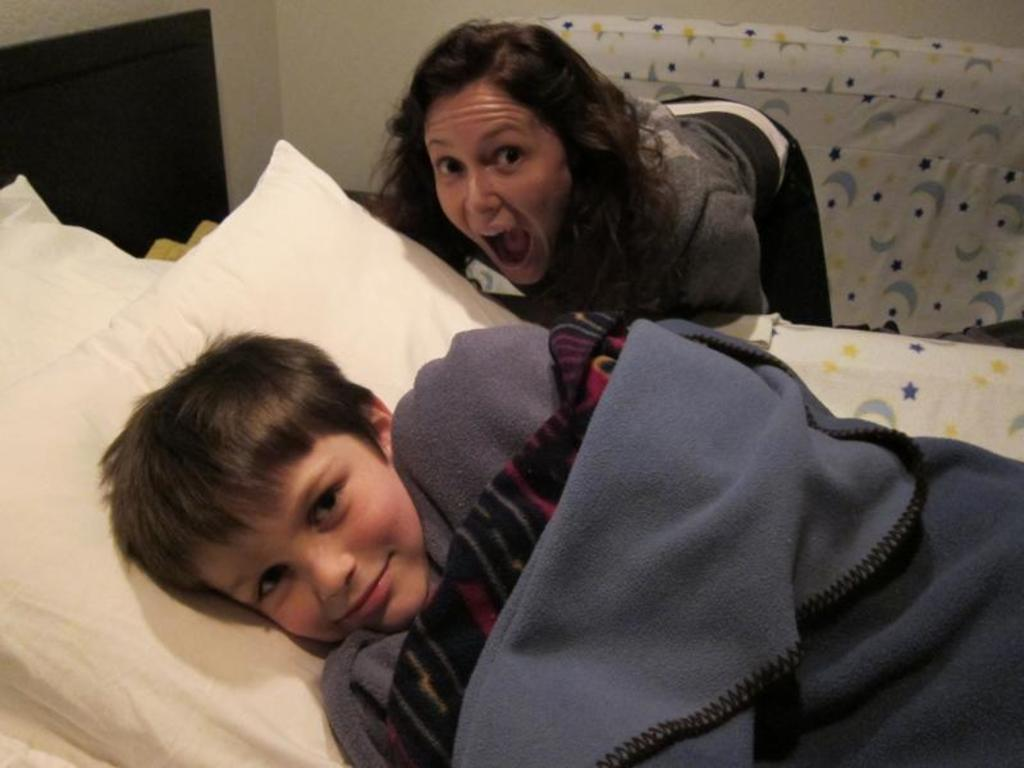Who is the main subject in the image? There is a boy in the image. What is the boy doing in the image? The boy is sleeping on a bed. What is on the bed with the boy? There is a pillow on the bed. Who is present near the boy in the image? There is a woman standing near the boy. What is the boy using to cover himself in the image? The boy is covering himself with a blanket. What type of curve can be seen in the yarn that the boy is using to transport himself in the image? There is no yarn or transportation device present in the image; the boy is sleeping on a bed and is not using any yarn to move around. 